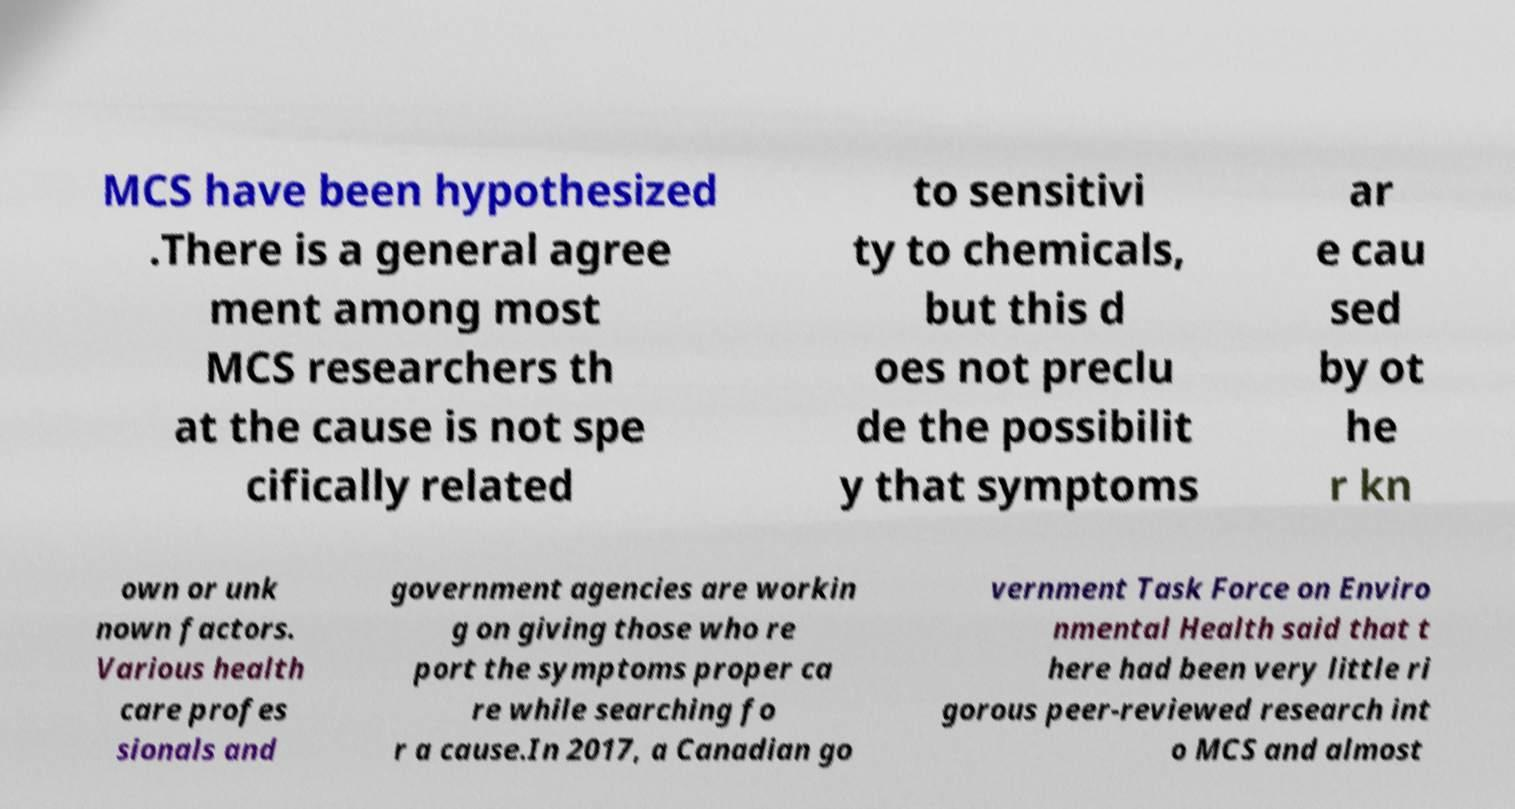What messages or text are displayed in this image? I need them in a readable, typed format. MCS have been hypothesized .There is a general agree ment among most MCS researchers th at the cause is not spe cifically related to sensitivi ty to chemicals, but this d oes not preclu de the possibilit y that symptoms ar e cau sed by ot he r kn own or unk nown factors. Various health care profes sionals and government agencies are workin g on giving those who re port the symptoms proper ca re while searching fo r a cause.In 2017, a Canadian go vernment Task Force on Enviro nmental Health said that t here had been very little ri gorous peer-reviewed research int o MCS and almost 